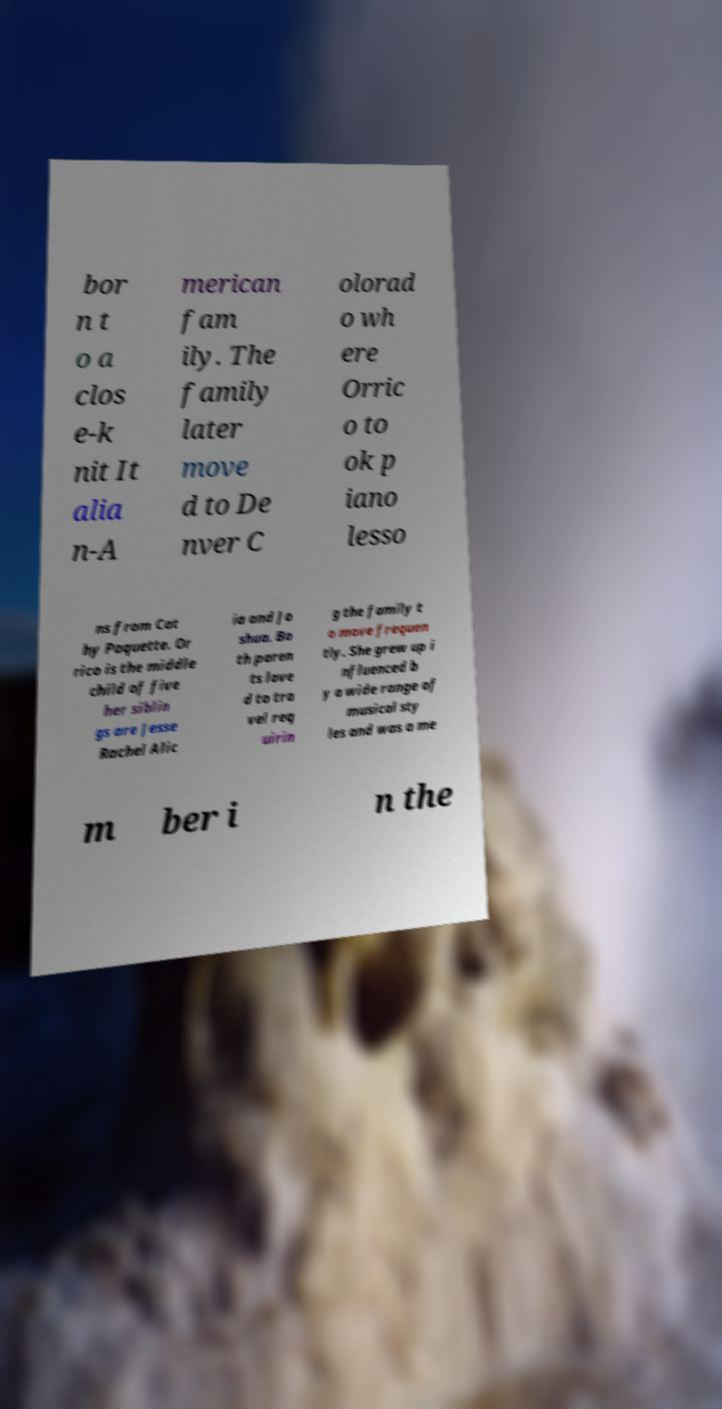Could you extract and type out the text from this image? bor n t o a clos e-k nit It alia n-A merican fam ily. The family later move d to De nver C olorad o wh ere Orric o to ok p iano lesso ns from Cat hy Paquette. Or rico is the middle child of five her siblin gs are Jesse Rachel Alic ia and Jo shua. Bo th paren ts love d to tra vel req uirin g the family t o move frequen tly. She grew up i nfluenced b y a wide range of musical sty les and was a me m ber i n the 